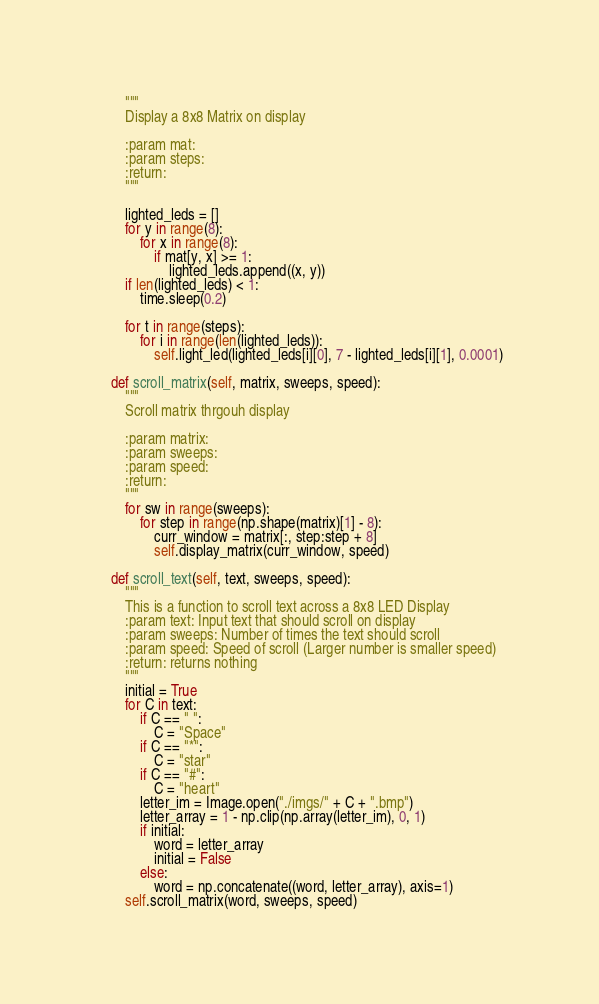Convert code to text. <code><loc_0><loc_0><loc_500><loc_500><_Python_>        """
        Display a 8x8 Matrix on display

        :param mat:
        :param steps:
        :return:
        """

        lighted_leds = []
        for y in range(8):
            for x in range(8):
                if mat[y, x] >= 1:
                    lighted_leds.append((x, y))
        if len(lighted_leds) < 1:
            time.sleep(0.2)

        for t in range(steps):
            for i in range(len(lighted_leds)):
                self.light_led(lighted_leds[i][0], 7 - lighted_leds[i][1], 0.0001)

    def scroll_matrix(self, matrix, sweeps, speed):
        """
        Scroll matrix thrgouh display

        :param matrix:
        :param sweeps:
        :param speed:
        :return:
        """
        for sw in range(sweeps):
            for step in range(np.shape(matrix)[1] - 8):
                curr_window = matrix[:, step:step + 8]
                self.display_matrix(curr_window, speed)

    def scroll_text(self, text, sweeps, speed):
        """
        This is a function to scroll text across a 8x8 LED Display
        :param text: Input text that should scroll on display
        :param sweeps: Number of times the text should scroll
        :param speed: Speed of scroll (Larger number is smaller speed)
        :return: returns nothing
        """
        initial = True
        for C in text:
            if C == " ":
                C = "Space"
            if C == "*":
                C = "star"
            if C == "#":
                C = "heart"
            letter_im = Image.open("./imgs/" + C + ".bmp")
            letter_array = 1 - np.clip(np.array(letter_im), 0, 1)
            if initial:
                word = letter_array
                initial = False
            else:
                word = np.concatenate((word, letter_array), axis=1)
        self.scroll_matrix(word, sweeps, speed)
</code> 